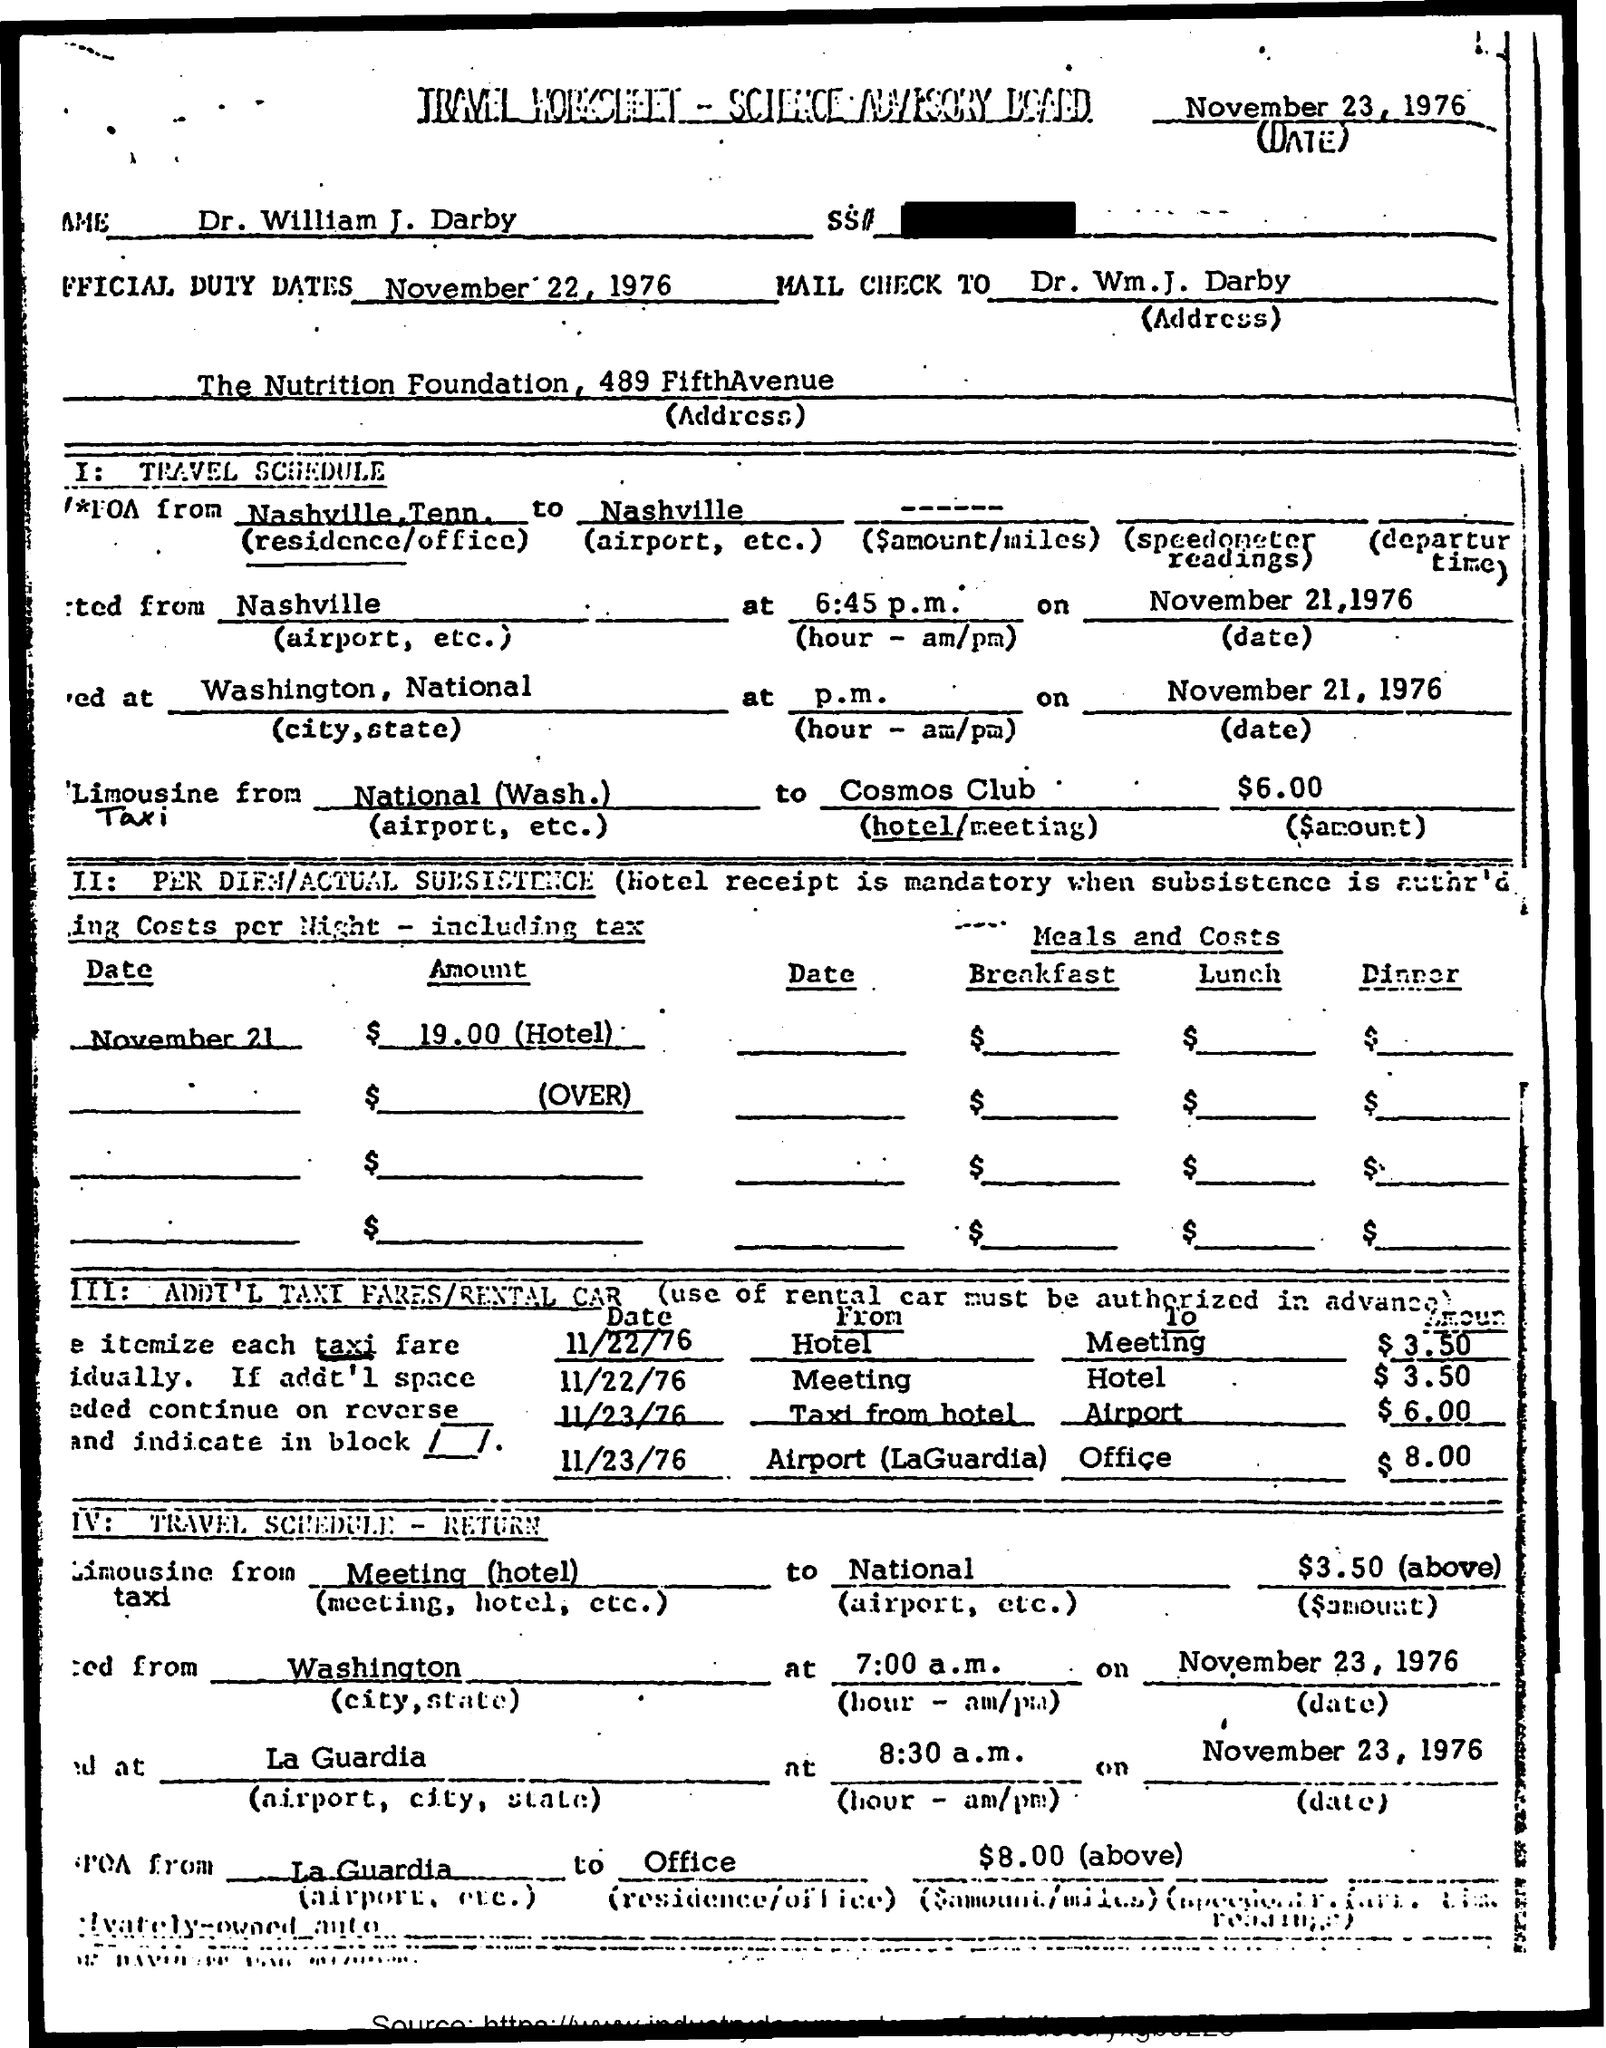Indicate a few pertinent items in this graphic. Dr. William J. Darby is named. The date mentioned is November 23, 1976. What is the official duty dates mentioned? November 22, 1976. 